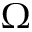Convert formula to latex. <formula><loc_0><loc_0><loc_500><loc_500>\Omega</formula> 